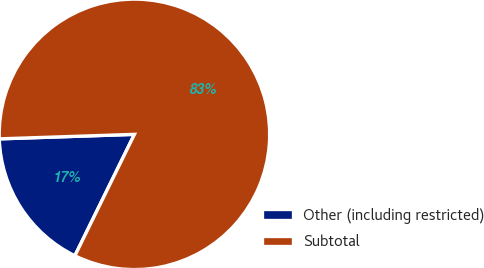Convert chart to OTSL. <chart><loc_0><loc_0><loc_500><loc_500><pie_chart><fcel>Other (including restricted)<fcel>Subtotal<nl><fcel>17.21%<fcel>82.79%<nl></chart> 